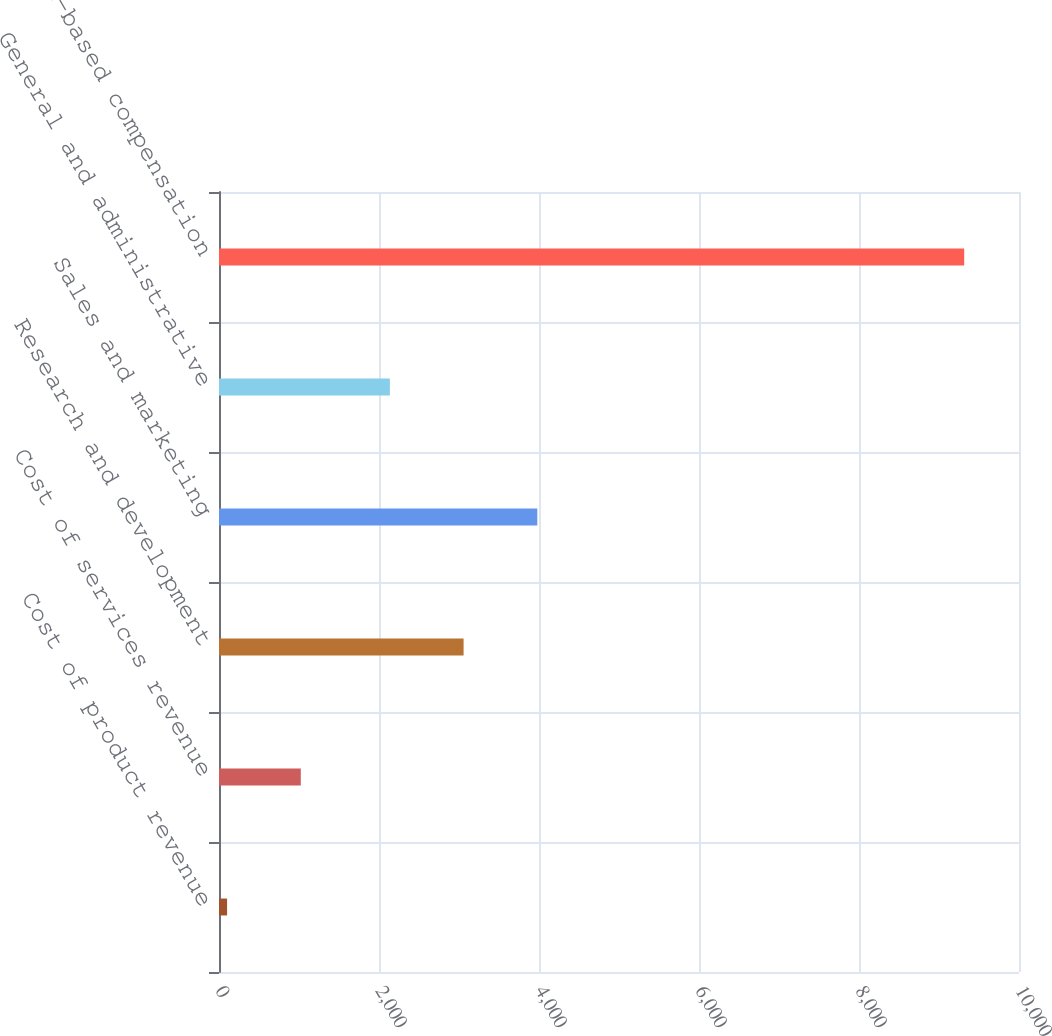Convert chart. <chart><loc_0><loc_0><loc_500><loc_500><bar_chart><fcel>Cost of product revenue<fcel>Cost of services revenue<fcel>Research and development<fcel>Sales and marketing<fcel>General and administrative<fcel>Total stock-based compensation<nl><fcel>101<fcel>1022.4<fcel>3057.4<fcel>3978.8<fcel>2136<fcel>9315<nl></chart> 